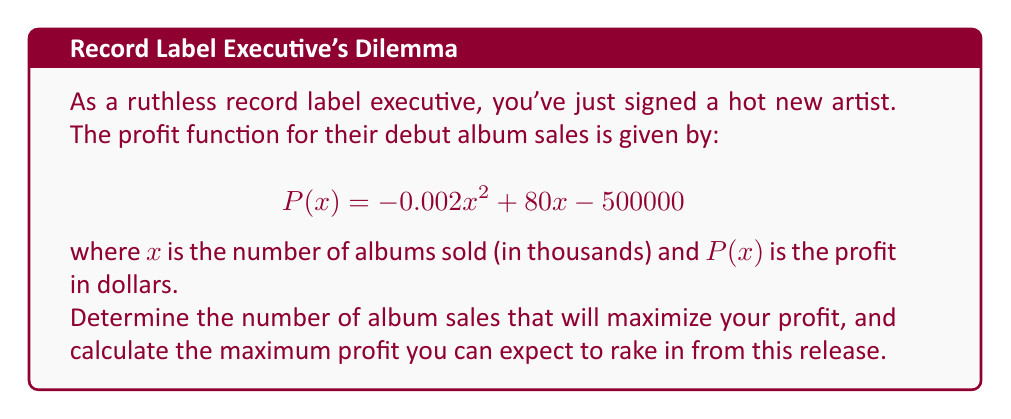Solve this math problem. To find the maximum profit point, we need to follow these steps:

1) The maximum profit occurs at the point where the derivative of the profit function equals zero. Let's find the derivative:

   $$P'(x) = -0.004x + 80$$

2) Set the derivative equal to zero and solve for x:

   $$-0.004x + 80 = 0$$
   $$-0.004x = -80$$
   $$x = 20000$$

3) This critical point represents 20,000 thousand albums, or 20 million albums.

4) To confirm this is a maximum (not a minimum), we can check the second derivative:

   $$P''(x) = -0.004$$

   Since this is negative, we confirm that x = 20000 gives a maximum.

5) To find the maximum profit, we plug this value back into our original profit function:

   $$P(20000) = -0.002(20000)^2 + 80(20000) - 500000$$
   $$= -800000 + 1600000 - 500000$$
   $$= 300000$$

Therefore, the maximum profit is $300,000.
Answer: 20 million albums; $300,000 